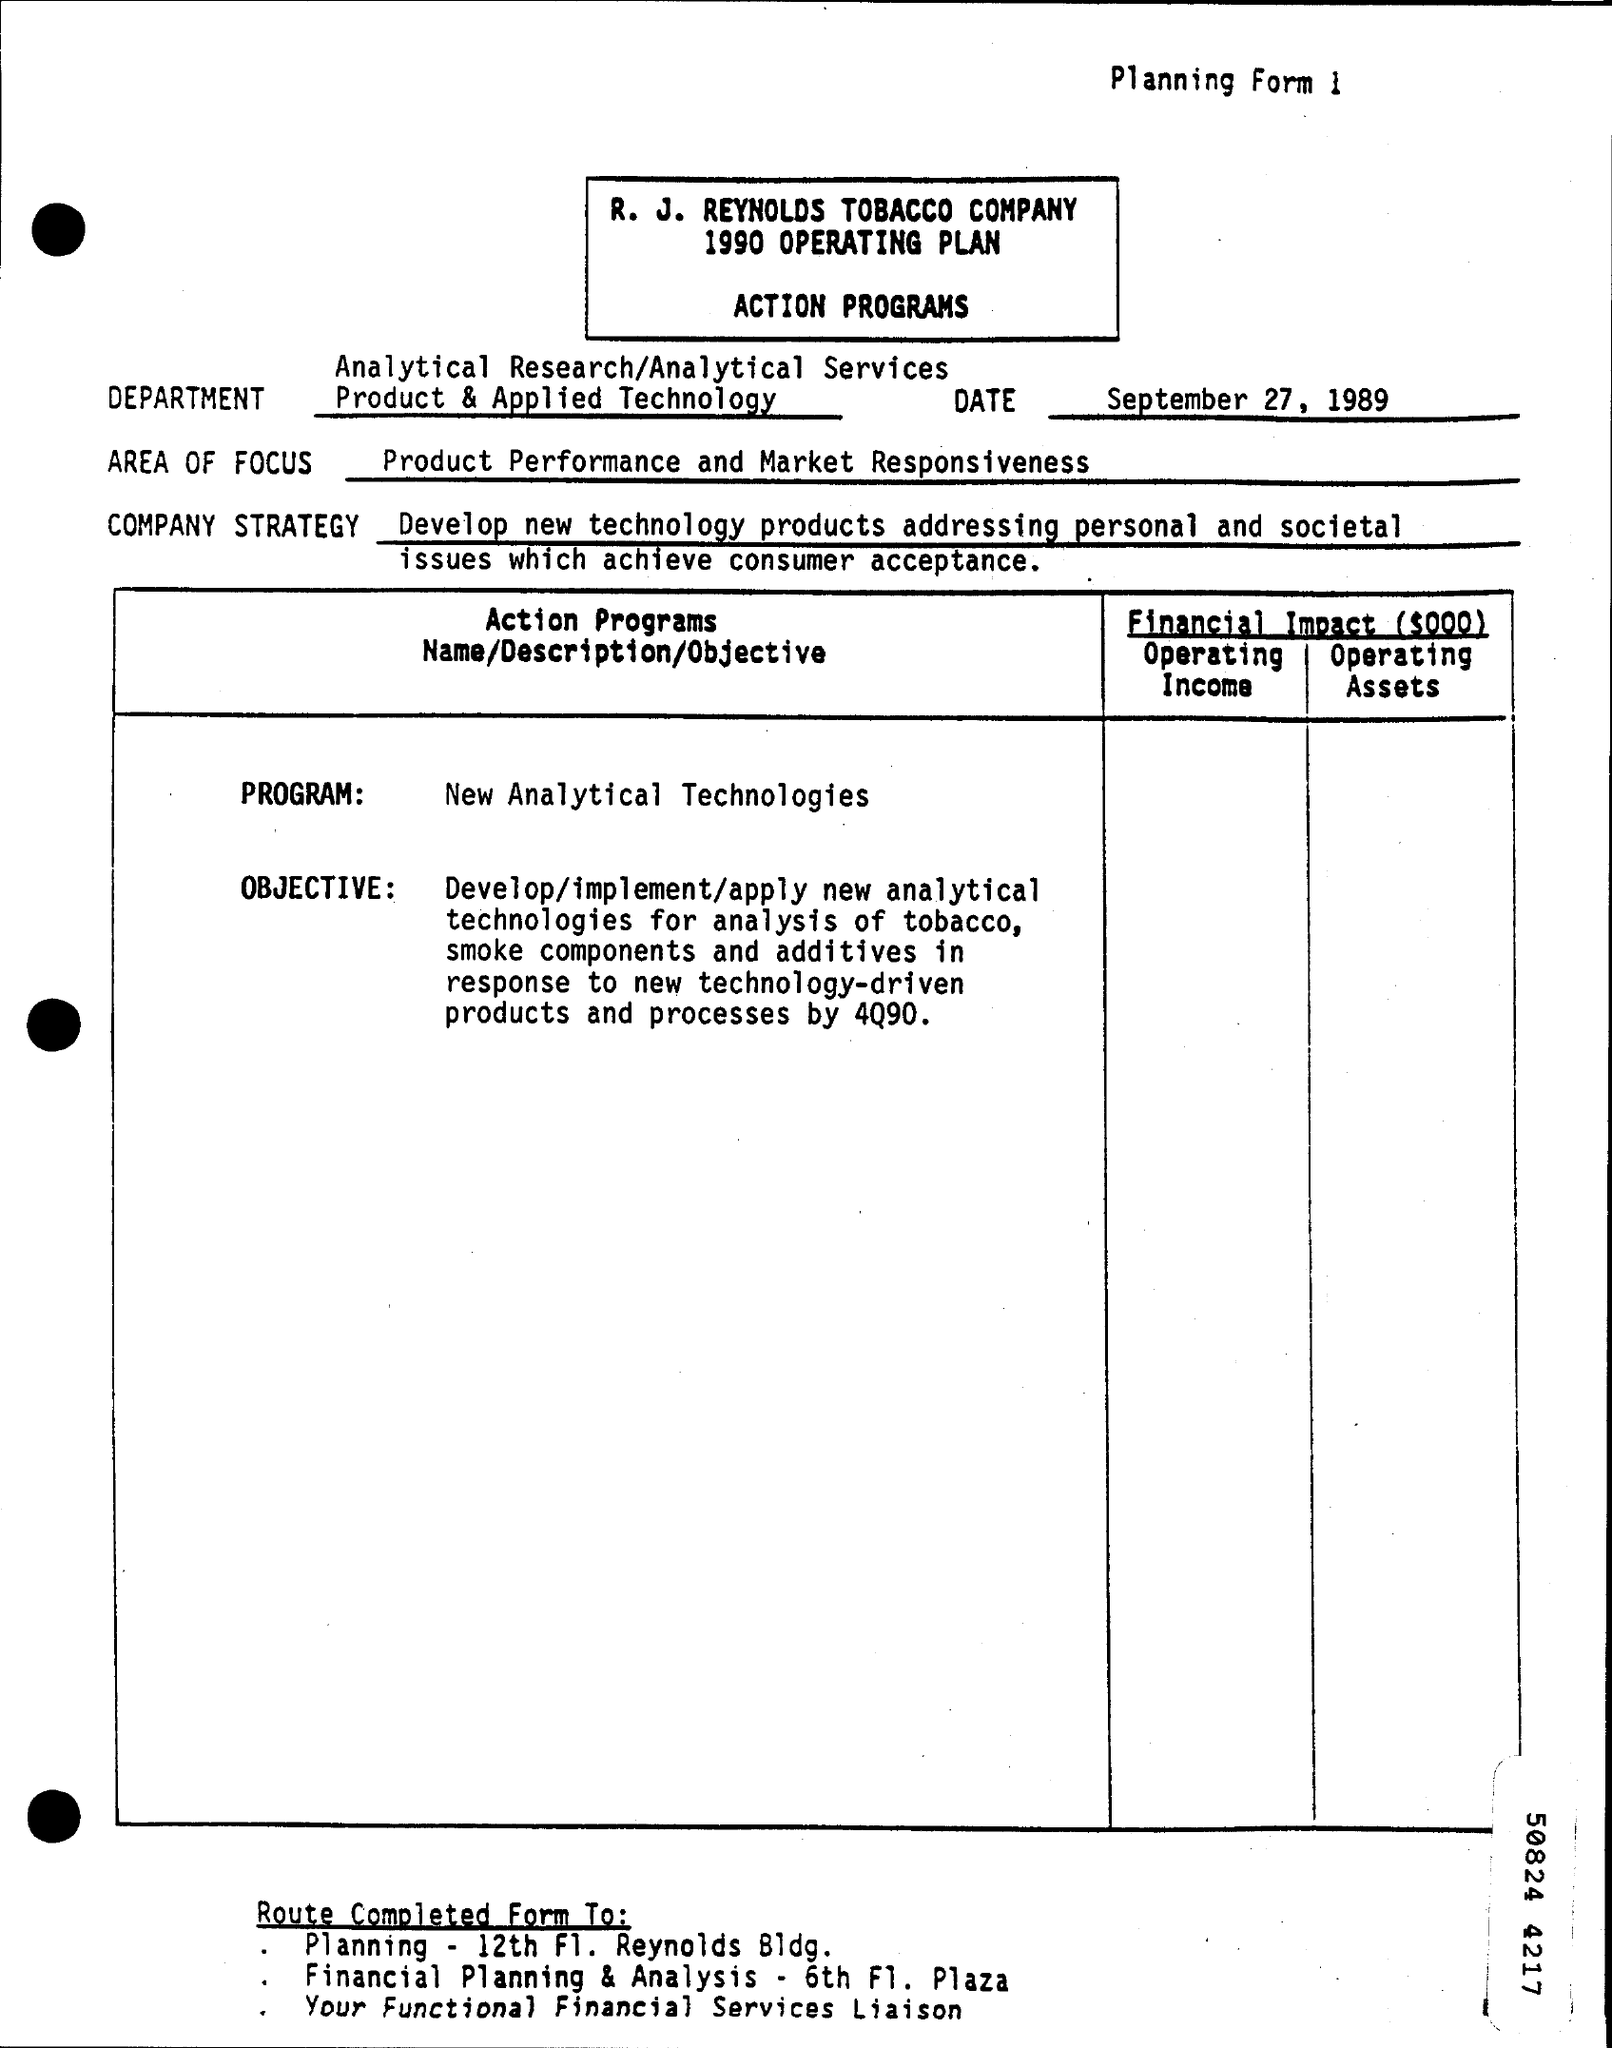Highlight a few significant elements in this photo. The year of the operating plan is 1990. The area of focus is on product performance and market responsiveness. The date on the form is September 27, 1989. 